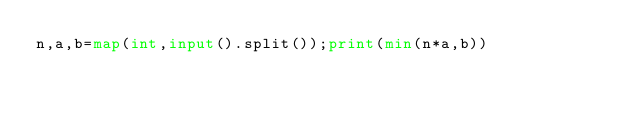Convert code to text. <code><loc_0><loc_0><loc_500><loc_500><_Python_>n,a,b=map(int,input().split());print(min(n*a,b))</code> 